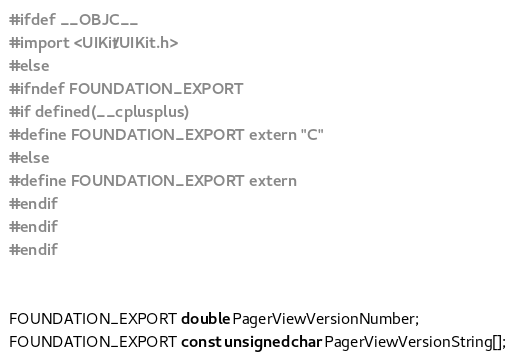Convert code to text. <code><loc_0><loc_0><loc_500><loc_500><_C_>#ifdef __OBJC__
#import <UIKit/UIKit.h>
#else
#ifndef FOUNDATION_EXPORT
#if defined(__cplusplus)
#define FOUNDATION_EXPORT extern "C"
#else
#define FOUNDATION_EXPORT extern
#endif
#endif
#endif


FOUNDATION_EXPORT double PagerViewVersionNumber;
FOUNDATION_EXPORT const unsigned char PagerViewVersionString[];

</code> 